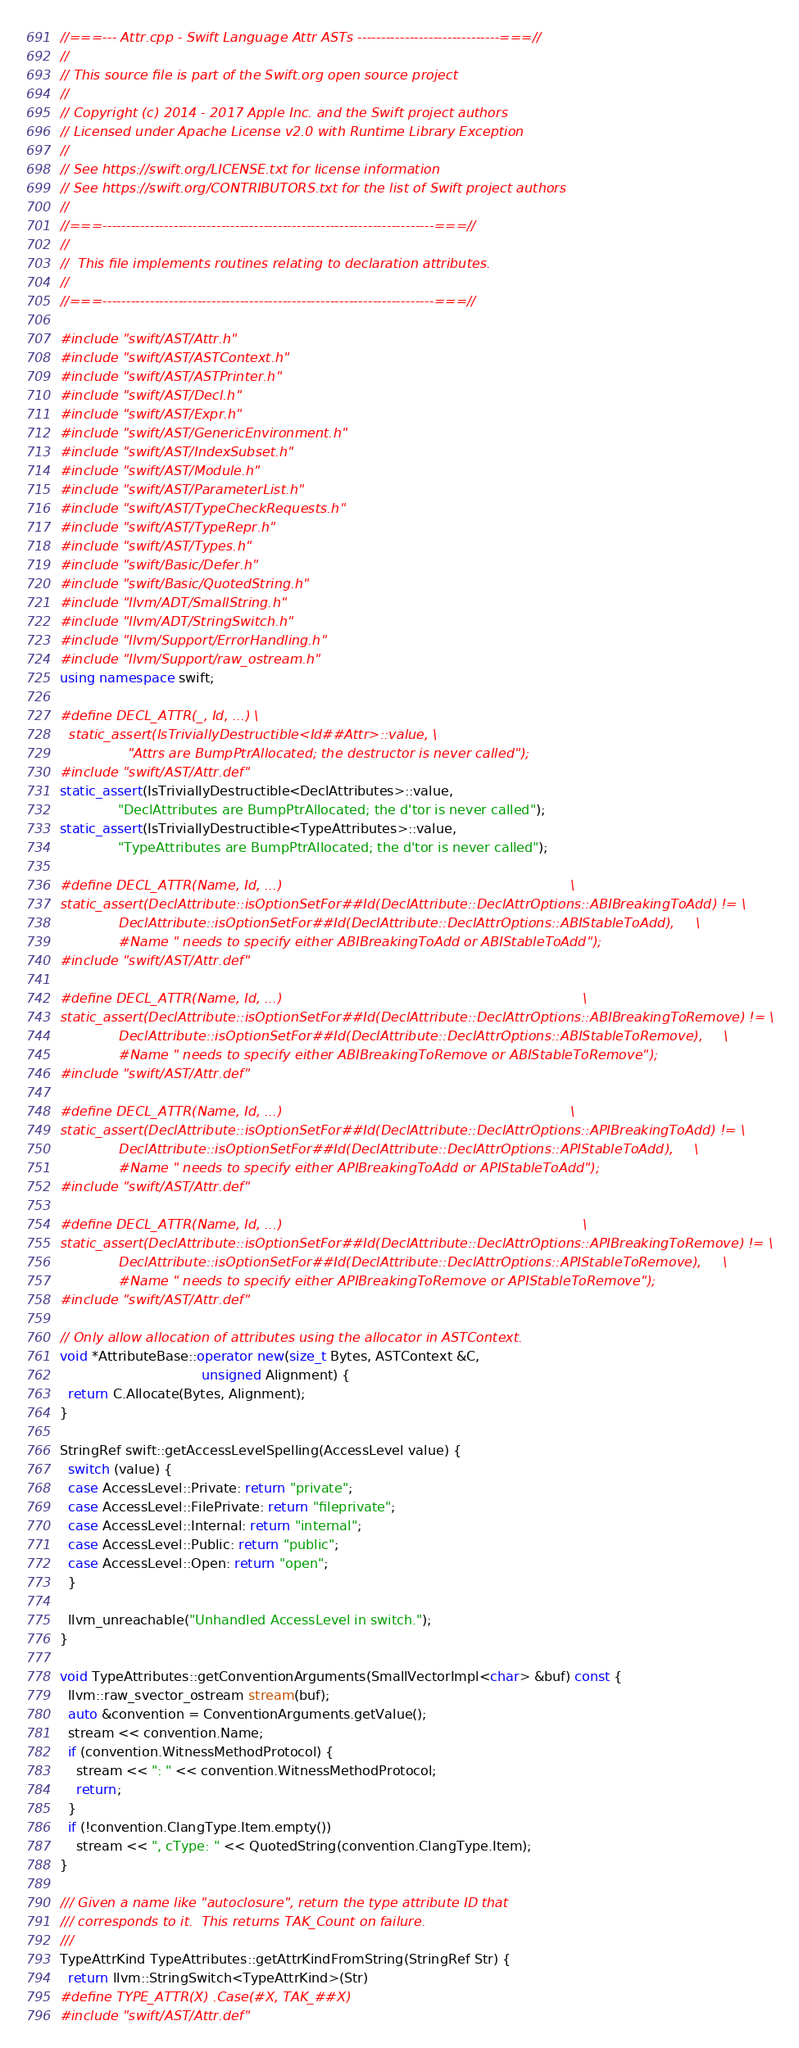<code> <loc_0><loc_0><loc_500><loc_500><_C++_>//===--- Attr.cpp - Swift Language Attr ASTs ------------------------------===//
//
// This source file is part of the Swift.org open source project
//
// Copyright (c) 2014 - 2017 Apple Inc. and the Swift project authors
// Licensed under Apache License v2.0 with Runtime Library Exception
//
// See https://swift.org/LICENSE.txt for license information
// See https://swift.org/CONTRIBUTORS.txt for the list of Swift project authors
//
//===----------------------------------------------------------------------===//
//
//  This file implements routines relating to declaration attributes.
//
//===----------------------------------------------------------------------===//

#include "swift/AST/Attr.h"
#include "swift/AST/ASTContext.h"
#include "swift/AST/ASTPrinter.h"
#include "swift/AST/Decl.h"
#include "swift/AST/Expr.h"
#include "swift/AST/GenericEnvironment.h"
#include "swift/AST/IndexSubset.h"
#include "swift/AST/Module.h"
#include "swift/AST/ParameterList.h"
#include "swift/AST/TypeCheckRequests.h"
#include "swift/AST/TypeRepr.h"
#include "swift/AST/Types.h"
#include "swift/Basic/Defer.h"
#include "swift/Basic/QuotedString.h"
#include "llvm/ADT/SmallString.h"
#include "llvm/ADT/StringSwitch.h"
#include "llvm/Support/ErrorHandling.h"
#include "llvm/Support/raw_ostream.h"
using namespace swift;

#define DECL_ATTR(_, Id, ...) \
  static_assert(IsTriviallyDestructible<Id##Attr>::value, \
                "Attrs are BumpPtrAllocated; the destructor is never called");
#include "swift/AST/Attr.def"
static_assert(IsTriviallyDestructible<DeclAttributes>::value,
              "DeclAttributes are BumpPtrAllocated; the d'tor is never called");
static_assert(IsTriviallyDestructible<TypeAttributes>::value,
              "TypeAttributes are BumpPtrAllocated; the d'tor is never called");

#define DECL_ATTR(Name, Id, ...)                                                                     \
static_assert(DeclAttribute::isOptionSetFor##Id(DeclAttribute::DeclAttrOptions::ABIBreakingToAdd) != \
              DeclAttribute::isOptionSetFor##Id(DeclAttribute::DeclAttrOptions::ABIStableToAdd),     \
              #Name " needs to specify either ABIBreakingToAdd or ABIStableToAdd");
#include "swift/AST/Attr.def"

#define DECL_ATTR(Name, Id, ...)                                                                        \
static_assert(DeclAttribute::isOptionSetFor##Id(DeclAttribute::DeclAttrOptions::ABIBreakingToRemove) != \
              DeclAttribute::isOptionSetFor##Id(DeclAttribute::DeclAttrOptions::ABIStableToRemove),     \
              #Name " needs to specify either ABIBreakingToRemove or ABIStableToRemove");
#include "swift/AST/Attr.def"

#define DECL_ATTR(Name, Id, ...)                                                                     \
static_assert(DeclAttribute::isOptionSetFor##Id(DeclAttribute::DeclAttrOptions::APIBreakingToAdd) != \
              DeclAttribute::isOptionSetFor##Id(DeclAttribute::DeclAttrOptions::APIStableToAdd),     \
              #Name " needs to specify either APIBreakingToAdd or APIStableToAdd");
#include "swift/AST/Attr.def"

#define DECL_ATTR(Name, Id, ...)                                                                        \
static_assert(DeclAttribute::isOptionSetFor##Id(DeclAttribute::DeclAttrOptions::APIBreakingToRemove) != \
              DeclAttribute::isOptionSetFor##Id(DeclAttribute::DeclAttrOptions::APIStableToRemove),     \
              #Name " needs to specify either APIBreakingToRemove or APIStableToRemove");
#include "swift/AST/Attr.def"

// Only allow allocation of attributes using the allocator in ASTContext.
void *AttributeBase::operator new(size_t Bytes, ASTContext &C,
                                  unsigned Alignment) {
  return C.Allocate(Bytes, Alignment);
}

StringRef swift::getAccessLevelSpelling(AccessLevel value) {
  switch (value) {
  case AccessLevel::Private: return "private";
  case AccessLevel::FilePrivate: return "fileprivate";
  case AccessLevel::Internal: return "internal";
  case AccessLevel::Public: return "public";
  case AccessLevel::Open: return "open";
  }

  llvm_unreachable("Unhandled AccessLevel in switch.");
}

void TypeAttributes::getConventionArguments(SmallVectorImpl<char> &buf) const {
  llvm::raw_svector_ostream stream(buf);
  auto &convention = ConventionArguments.getValue();
  stream << convention.Name;
  if (convention.WitnessMethodProtocol) {
    stream << ": " << convention.WitnessMethodProtocol;
    return;
  }
  if (!convention.ClangType.Item.empty())
    stream << ", cType: " << QuotedString(convention.ClangType.Item);
}

/// Given a name like "autoclosure", return the type attribute ID that
/// corresponds to it.  This returns TAK_Count on failure.
///
TypeAttrKind TypeAttributes::getAttrKindFromString(StringRef Str) {
  return llvm::StringSwitch<TypeAttrKind>(Str)
#define TYPE_ATTR(X) .Case(#X, TAK_##X)
#include "swift/AST/Attr.def"</code> 